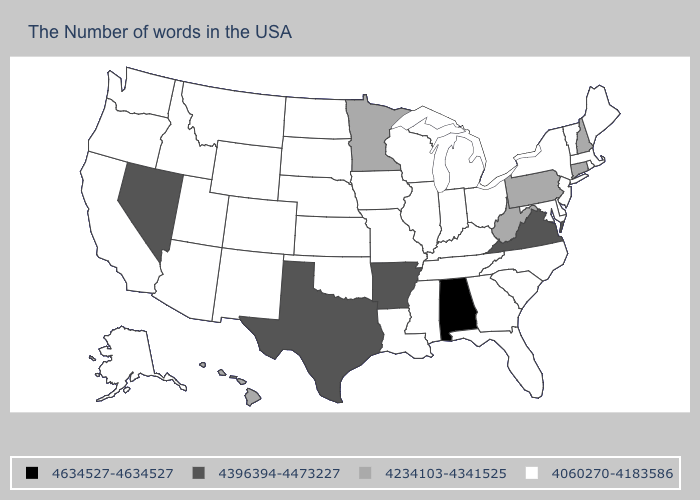What is the value of Tennessee?
Answer briefly. 4060270-4183586. Does Wyoming have the lowest value in the West?
Short answer required. Yes. Among the states that border Texas , which have the lowest value?
Answer briefly. Louisiana, Oklahoma, New Mexico. What is the value of New Mexico?
Keep it brief. 4060270-4183586. Which states have the highest value in the USA?
Give a very brief answer. Alabama. Among the states that border Tennessee , does Missouri have the lowest value?
Give a very brief answer. Yes. Name the states that have a value in the range 4396394-4473227?
Answer briefly. Virginia, Arkansas, Texas, Nevada. Name the states that have a value in the range 4060270-4183586?
Give a very brief answer. Maine, Massachusetts, Rhode Island, Vermont, New York, New Jersey, Delaware, Maryland, North Carolina, South Carolina, Ohio, Florida, Georgia, Michigan, Kentucky, Indiana, Tennessee, Wisconsin, Illinois, Mississippi, Louisiana, Missouri, Iowa, Kansas, Nebraska, Oklahoma, South Dakota, North Dakota, Wyoming, Colorado, New Mexico, Utah, Montana, Arizona, Idaho, California, Washington, Oregon, Alaska. Name the states that have a value in the range 4234103-4341525?
Be succinct. New Hampshire, Connecticut, Pennsylvania, West Virginia, Minnesota, Hawaii. What is the lowest value in the USA?
Write a very short answer. 4060270-4183586. What is the lowest value in the USA?
Quick response, please. 4060270-4183586. Does California have the same value as Texas?
Answer briefly. No. Which states have the lowest value in the USA?
Answer briefly. Maine, Massachusetts, Rhode Island, Vermont, New York, New Jersey, Delaware, Maryland, North Carolina, South Carolina, Ohio, Florida, Georgia, Michigan, Kentucky, Indiana, Tennessee, Wisconsin, Illinois, Mississippi, Louisiana, Missouri, Iowa, Kansas, Nebraska, Oklahoma, South Dakota, North Dakota, Wyoming, Colorado, New Mexico, Utah, Montana, Arizona, Idaho, California, Washington, Oregon, Alaska. Does New York have the same value as West Virginia?
Keep it brief. No. What is the lowest value in the MidWest?
Keep it brief. 4060270-4183586. 